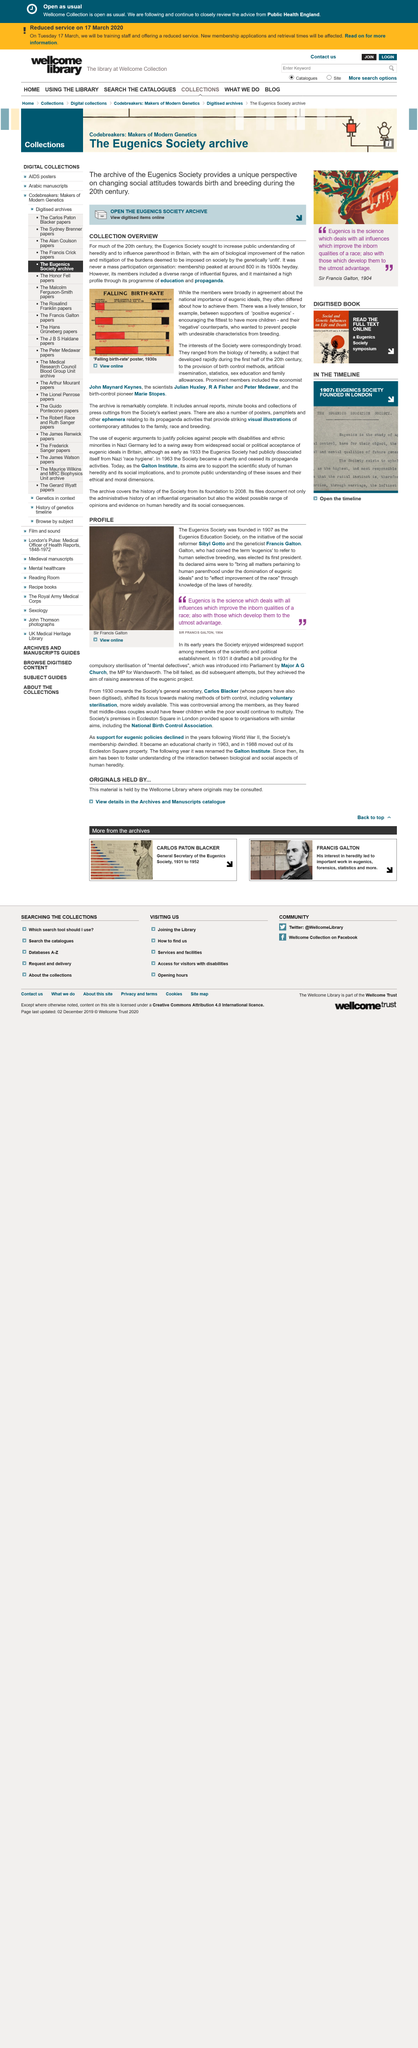Point out several critical features in this image. The Eugenics Society experienced its peak membership in the 1930s, during its most prosperous period. For much of the 20th century, the Eugenics Society aimed to increase public understanding of heredity and influence parenthood in Britain with the goal of achieving biological improvement of the nation and reducing the burdens deemed to be imposed on society by individuals deemed to be genetically "unfit. Sibyl Gotto was the social reformer who founded the Eugenics Education Society. The peak membership for the Eugenics Society was approximately 800. Eugenics attempted to improve the human race by utilizing the laws of heredity to enhance the traits of individuals deemed superior and eliminate those deemed inferior. 